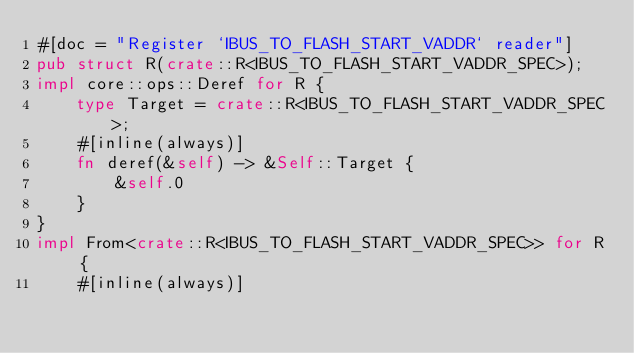<code> <loc_0><loc_0><loc_500><loc_500><_Rust_>#[doc = "Register `IBUS_TO_FLASH_START_VADDR` reader"]
pub struct R(crate::R<IBUS_TO_FLASH_START_VADDR_SPEC>);
impl core::ops::Deref for R {
    type Target = crate::R<IBUS_TO_FLASH_START_VADDR_SPEC>;
    #[inline(always)]
    fn deref(&self) -> &Self::Target {
        &self.0
    }
}
impl From<crate::R<IBUS_TO_FLASH_START_VADDR_SPEC>> for R {
    #[inline(always)]</code> 